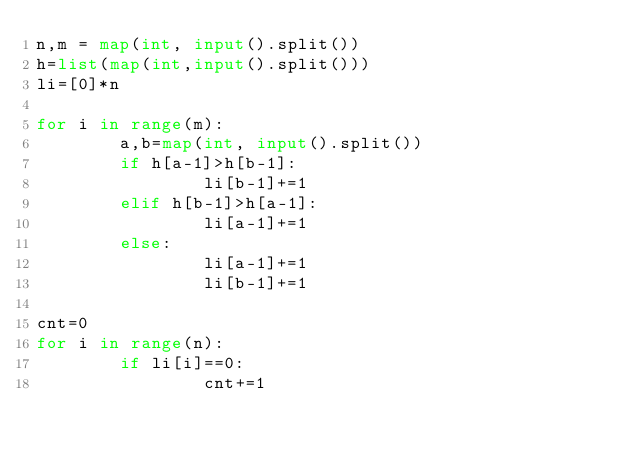Convert code to text. <code><loc_0><loc_0><loc_500><loc_500><_Python_>n,m = map(int, input().split())
h=list(map(int,input().split()))
li=[0]*n
 
for i in range(m):
        a,b=map(int, input().split())
        if h[a-1]>h[b-1]:
                li[b-1]+=1
        elif h[b-1]>h[a-1]:
                li[a-1]+=1
        else:
          		li[a-1]+=1
            	li[b-1]+=1
 
cnt=0
for i in range(n):
        if li[i]==0:
                cnt+=1</code> 